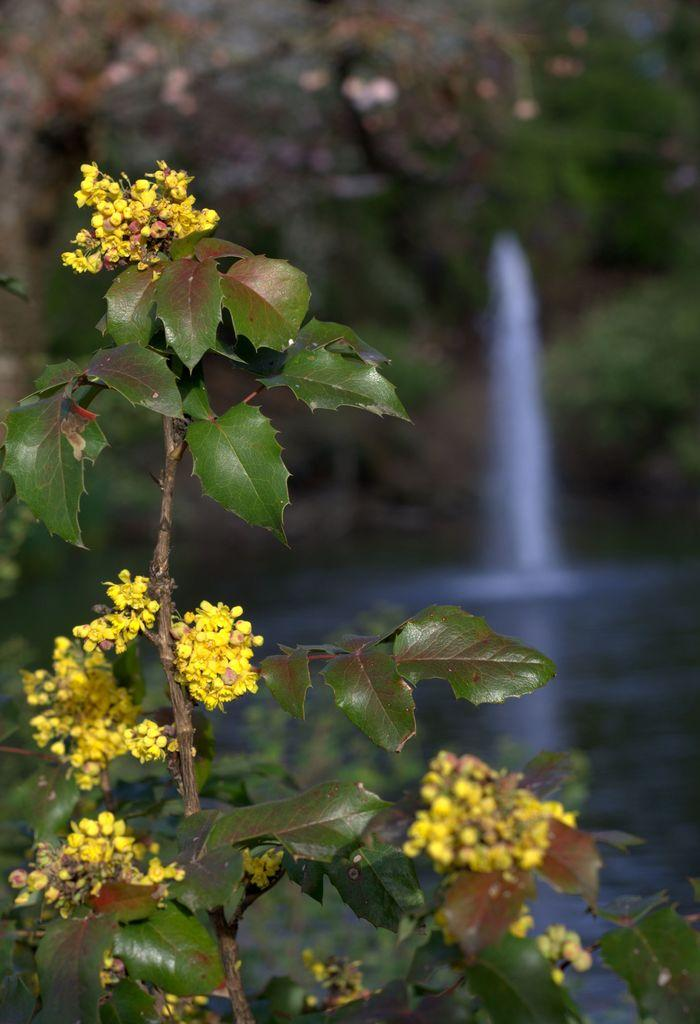What types of plants are in the foreground of the image? There are plants with flowers in the foreground of the image. What can be seen at the bottom of the image? There is water visible at the bottom of the image. What is visible in the background of the image? There are trees and a waterfall in the background of the image. What type of organization is responsible for maintaining the beef in the winter season in the image? A: There is no mention of beef or winter season in the image, and no organization is responsible for maintaining them. 